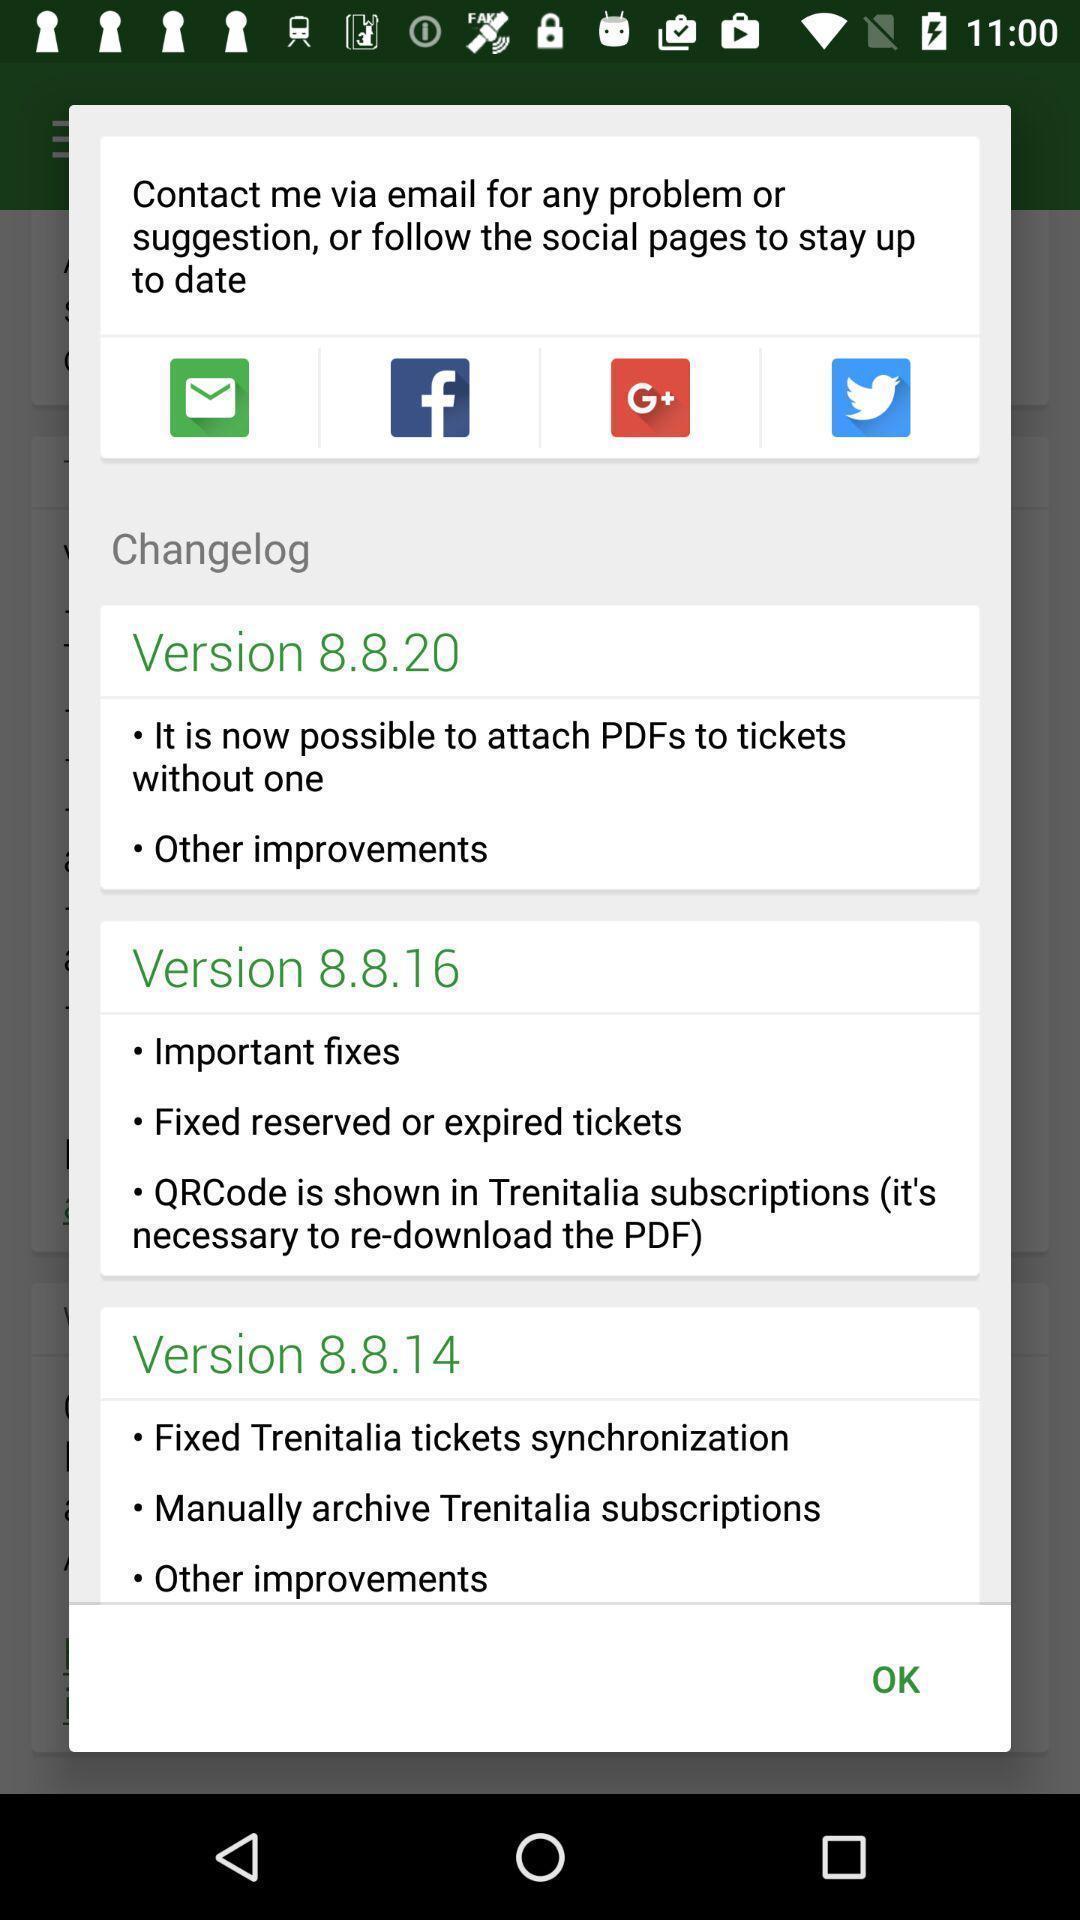Tell me what you see in this picture. Pop-up shows multiple version list. 